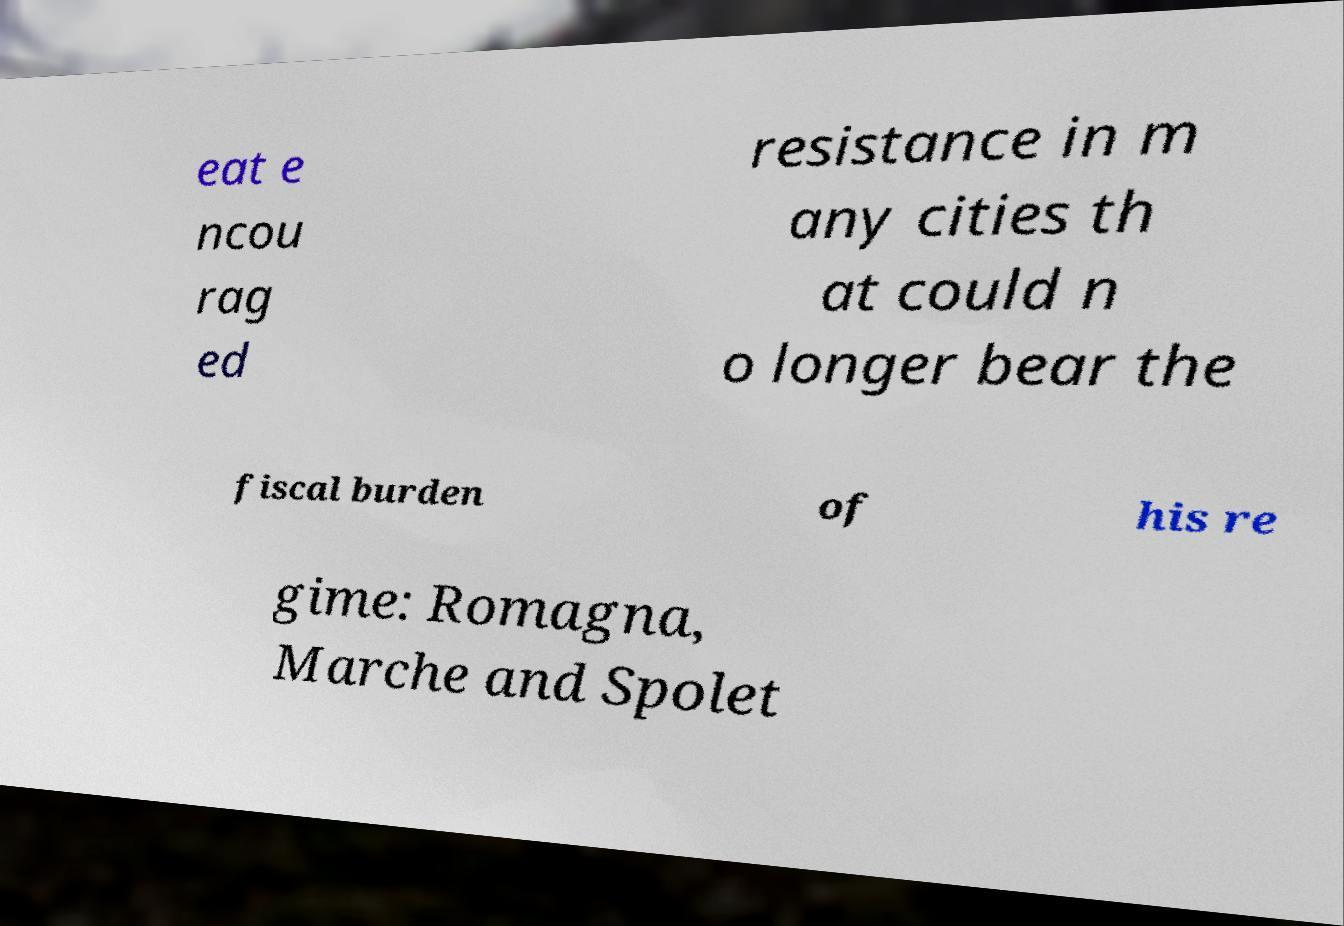Please identify and transcribe the text found in this image. eat e ncou rag ed resistance in m any cities th at could n o longer bear the fiscal burden of his re gime: Romagna, Marche and Spolet 